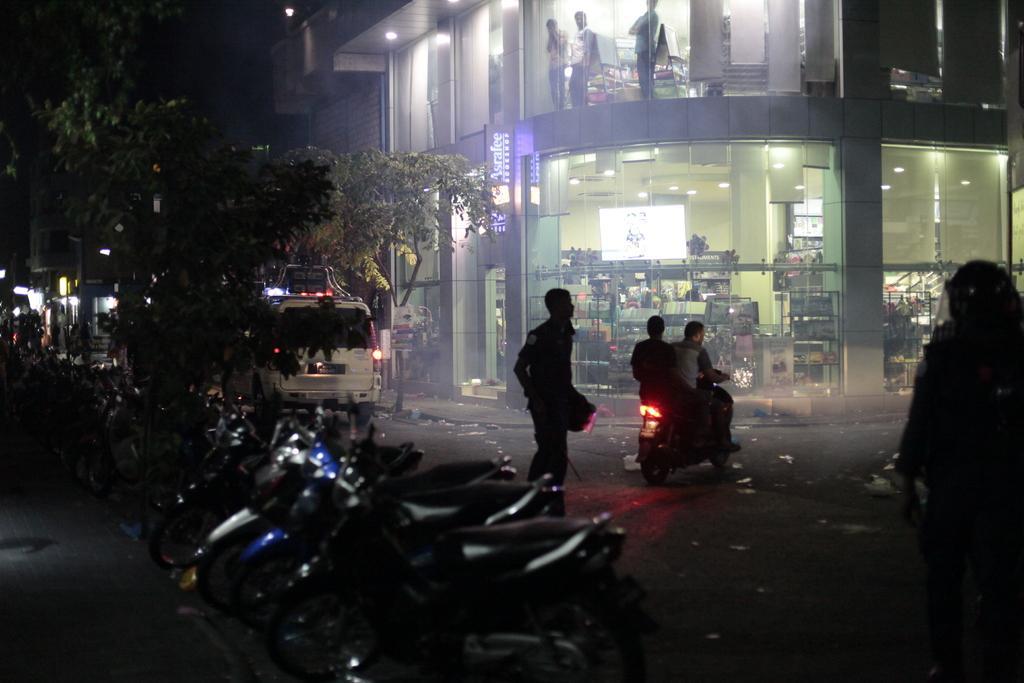Could you give a brief overview of what you see in this image? In this image there is a building, people, vehicles, tree and objects. In that building there are people, ceiling lights and objects. 